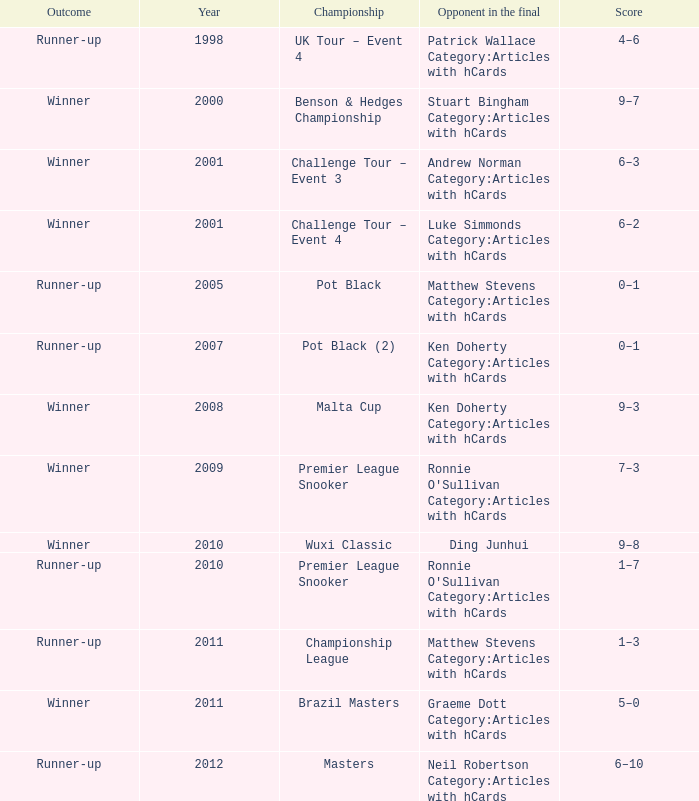What was Shaun Murphy's outcome in the Premier League Snooker championship held before 2010? Winner. 